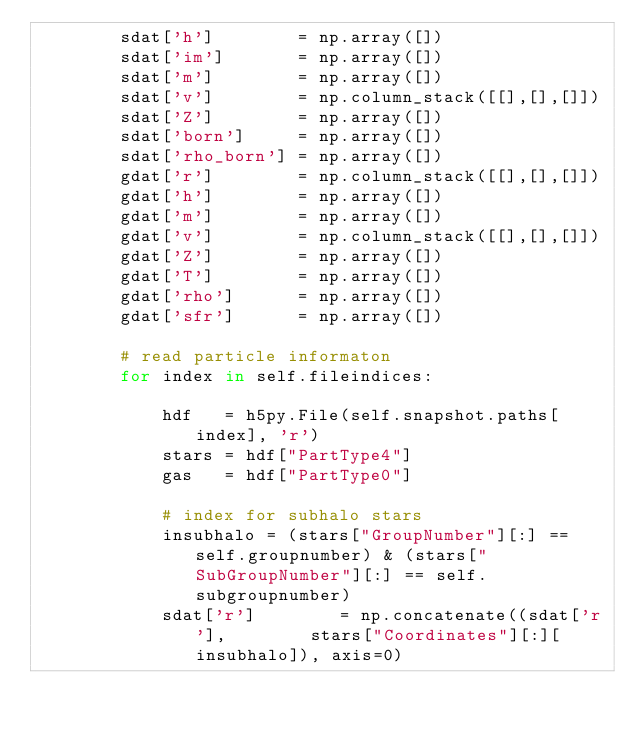Convert code to text. <code><loc_0><loc_0><loc_500><loc_500><_Python_>        sdat['h']        = np.array([])
        sdat['im']       = np.array([])
        sdat['m']        = np.array([])
        sdat['v']        = np.column_stack([[],[],[]])
        sdat['Z']        = np.array([])
        sdat['born']     = np.array([])
        sdat['rho_born'] = np.array([])
        gdat['r']        = np.column_stack([[],[],[]])
        gdat['h']        = np.array([])
        gdat['m']        = np.array([])
        gdat['v']        = np.column_stack([[],[],[]])
        gdat['Z']        = np.array([])
        gdat['T']        = np.array([])
        gdat['rho']      = np.array([])
        gdat['sfr']      = np.array([])

        # read particle informaton
        for index in self.fileindices:

            hdf   = h5py.File(self.snapshot.paths[index], 'r')
            stars = hdf["PartType4"]
            gas   = hdf["PartType0"]

            # index for subhalo stars
            insubhalo = (stars["GroupNumber"][:] == self.groupnumber) & (stars["SubGroupNumber"][:] == self.subgroupnumber)
            sdat['r']        = np.concatenate((sdat['r'],        stars["Coordinates"][:][insubhalo]), axis=0)</code> 